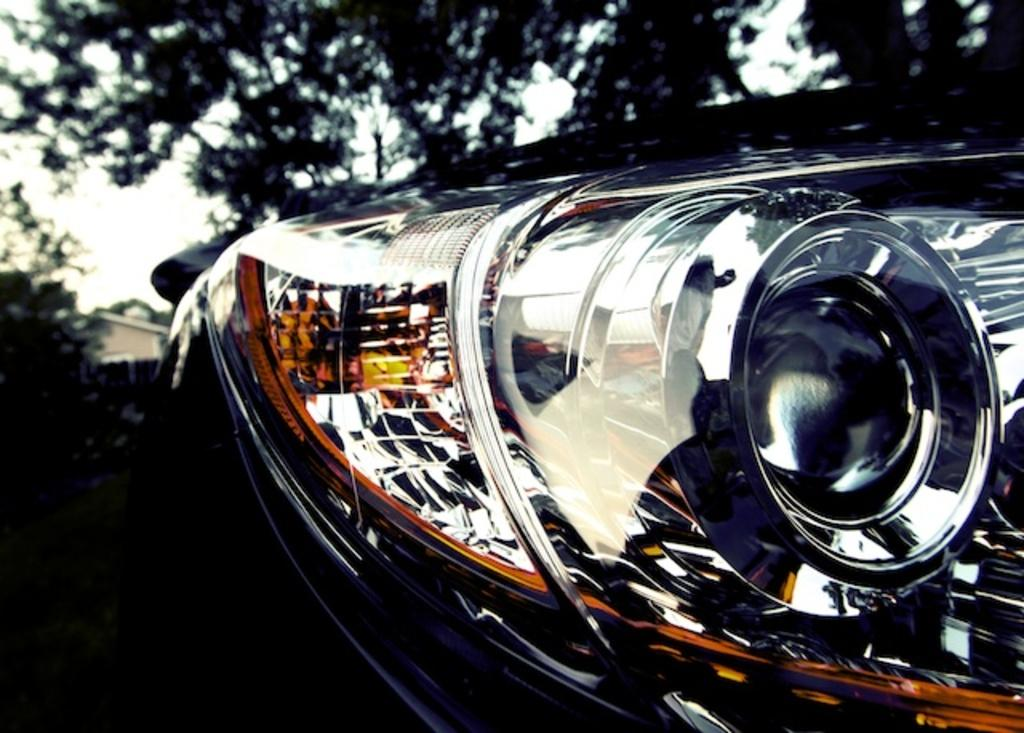What is the main focus of the image? The image shows a closeup view of a car's front light. What can be seen in the background of the image? There are plants and trees visible in the background. Can you describe the house in the background? A house is present in the background, but it appears blurry. How would you describe the weather based on the image? The sky is cloudy in the image, suggesting overcast or potentially rainy weather. How many legs can be seen supporting the car's front light in the image? There are no legs visible in the image, as the car's front light is a part of the car's body and does not require separate support. 